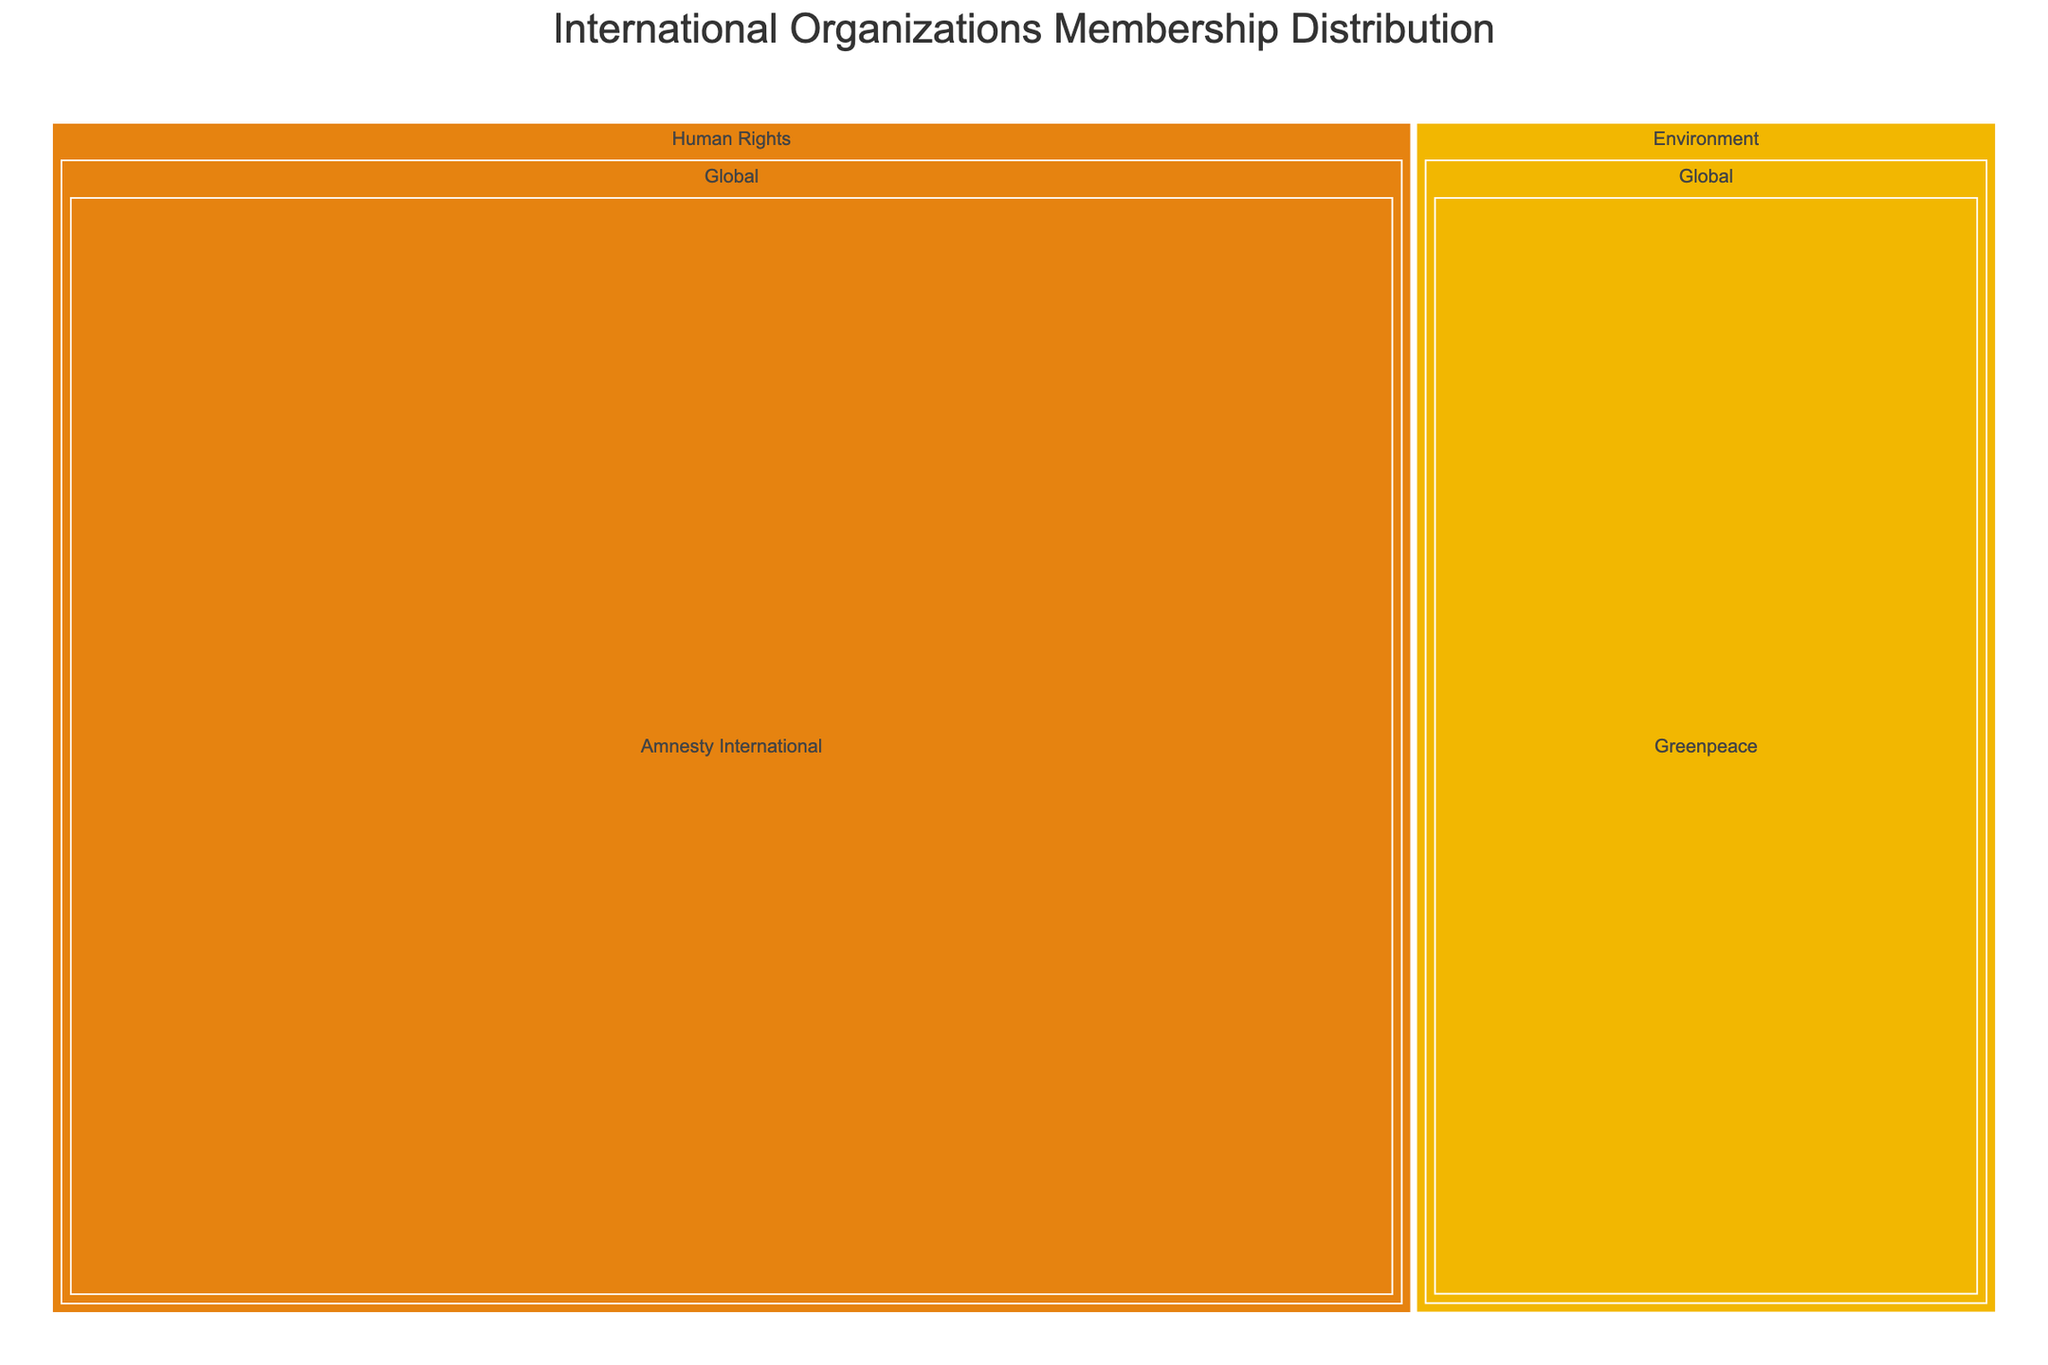Which organization has the highest membership count? By inspecting the size of the rectangles, we can see that Amnesty International has the largest rectangle, indicating the highest membership count.
Answer: Amnesty International Which focus area has the most organizations listed? The focus areas can be seen by the first level of the treemap. By counting the number of organizations in each focus area, we can identify the one with the most entries.
Answer: Human Rights What is the sum of memberships for the Global organizations in the "Health" focus area? By summing the membership count for "World Health Organization" under Global in the "Health" focus area, we get 194.
Answer: 194 Which organization in the "Trade" focus area has more members: the World Trade Organization or Mercosur? Comparing the size of the rectangles for both organizations, the World Trade Organization has more members than Mercosur.
Answer: World Trade Organization What is the geographical distribution of organizations in the "Environment" focus area? In the "Environment" focus area, there are one Global (Greenpeace) and one Regional (ASEAN) organization.
Answer: 1 Global, 1 Regional How does the membership of the World Health Organization compare to the World Trade Organization? Comparing the membership counts from the treemap, the World Health Organization has 194 members while the World Trade Organization has 164 members.
Answer: World Health Organization has more members What is the total membership count of all organizations in the "Peace and Security" focus area? Adding up the membership counts for both "United Nations" (193) and "NATO" (30), we get a total of 223.
Answer: 223 In the "Economic Development" focus area, which organization has fewer members, and by how much? Comparing the membership counts of "World Bank Group" (189) and "European Union" (27), the European Union has fewer members by (189 - 27) 162 members.
Answer: European Union by 162 members Which focus area has the highest combined membership count for its global organizations? Summing the membership counts for global organizations within each focus area: 
  - Peace and Security: 193 (UN)
  - Economic Development: 189 (WBG)
  - Human Rights: 7,000,000 (Amnesty International)
  - Environment: 3,000,000 (Greenpeace)
  - Health: 194 (WHO)
  - Trade: 164 (WTO)
  - Culture: 193 (UNESCO)
By comparing totals, Human Rights has the highest combined membership count.
Answer: Human Rights How many organizations are listed under regional scope across all focus areas? Count the number of organizations categorized under "Regional" across all focus areas:
  - Peace and Security: 1 (NATO)
  - Economic Development: 1 (EU)
  - Human Rights: 1 (ACHPR)
  - Environment: 1 (ASEAN)
  - Health: 1 (PAHO)
  - Trade: 1 (Mercosur)
  - Culture: 1 (ALECSO)
So there are 7 regional organizations in total.
Answer: 7 organizations 